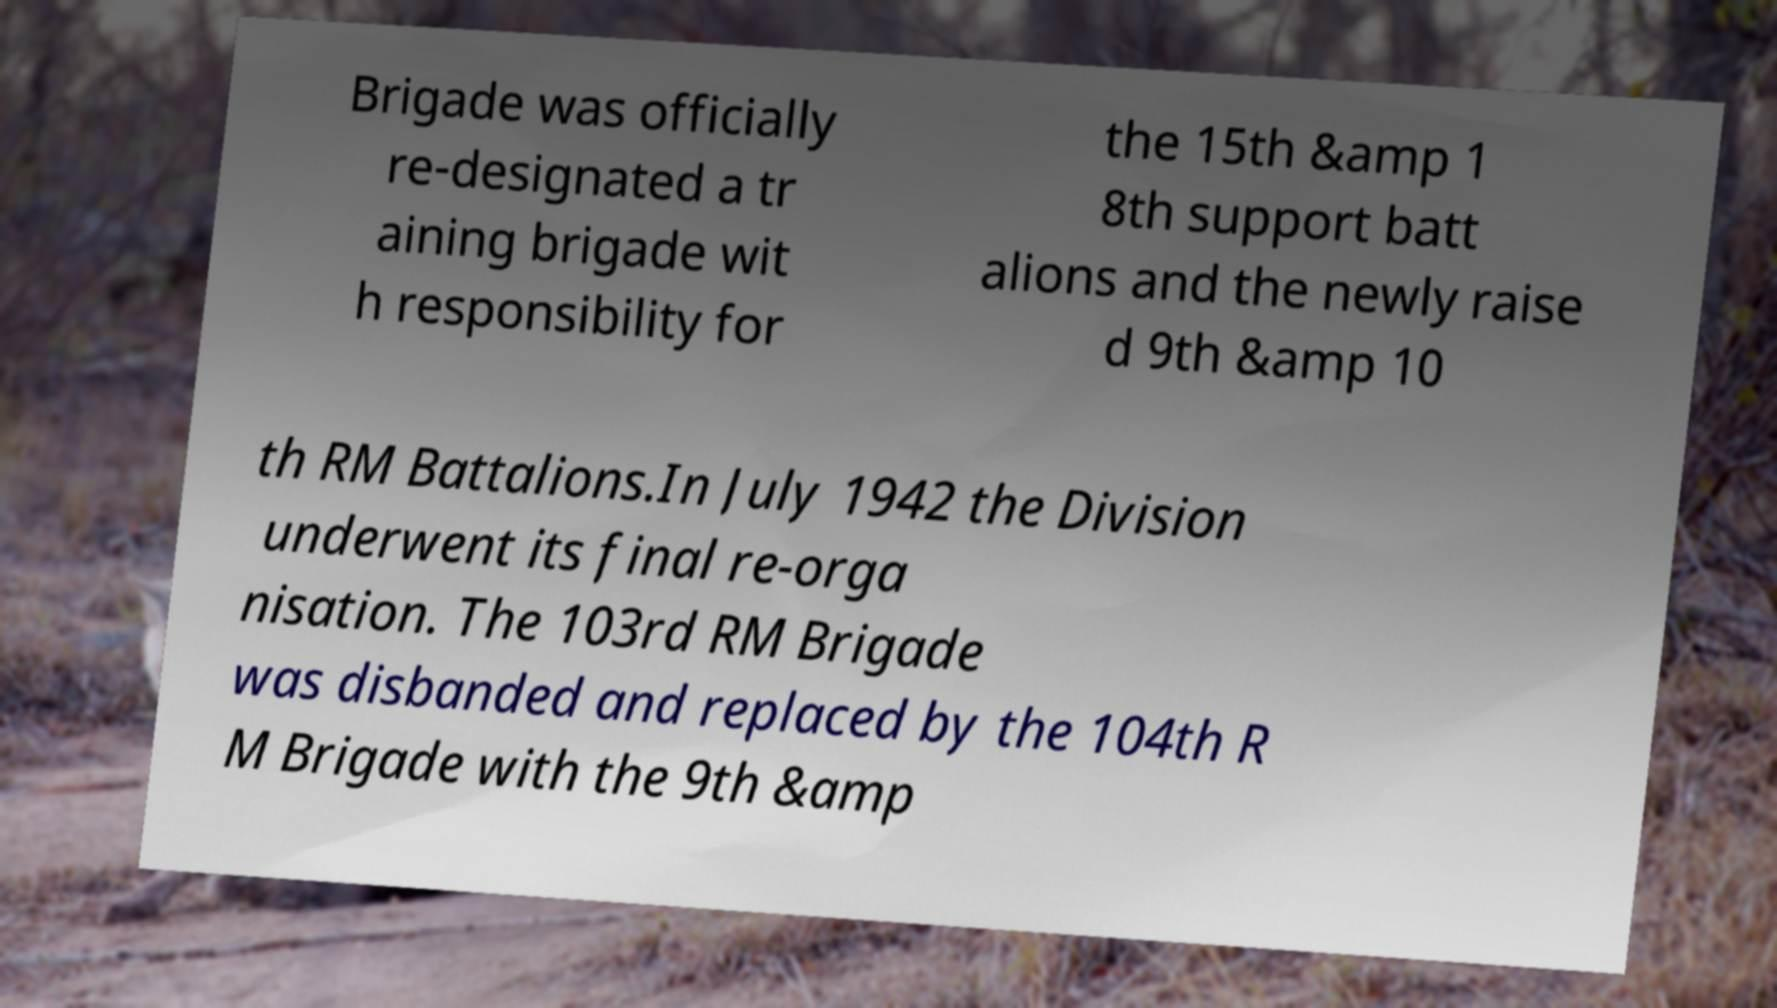Could you assist in decoding the text presented in this image and type it out clearly? Brigade was officially re-designated a tr aining brigade wit h responsibility for the 15th &amp 1 8th support batt alions and the newly raise d 9th &amp 10 th RM Battalions.In July 1942 the Division underwent its final re-orga nisation. The 103rd RM Brigade was disbanded and replaced by the 104th R M Brigade with the 9th &amp 